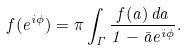Convert formula to latex. <formula><loc_0><loc_0><loc_500><loc_500>f ( e ^ { i \phi } ) = { \pi } \int _ { \Gamma } \frac { f ( a ) \, d a } { 1 - \bar { a } e ^ { i \phi } } .</formula> 